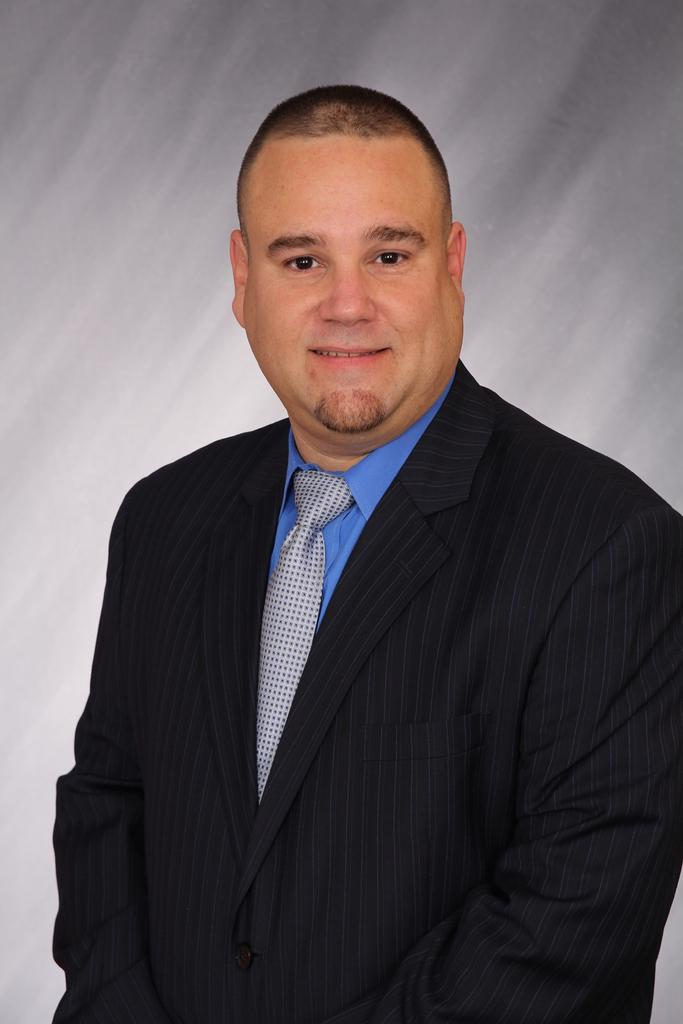What is the color of the background in the image? The background of the image is gray in color. Who or what is the main subject in the image? There is a man in the middle of the image. What is the facial expression of the man in the image? The man has a smiling face. How many rabbits can be seen hopping in the background of the image? There are no rabbits present in the image; the background is gray. What is the mass of the man in the image? The mass of the man cannot be determined from the image alone. 